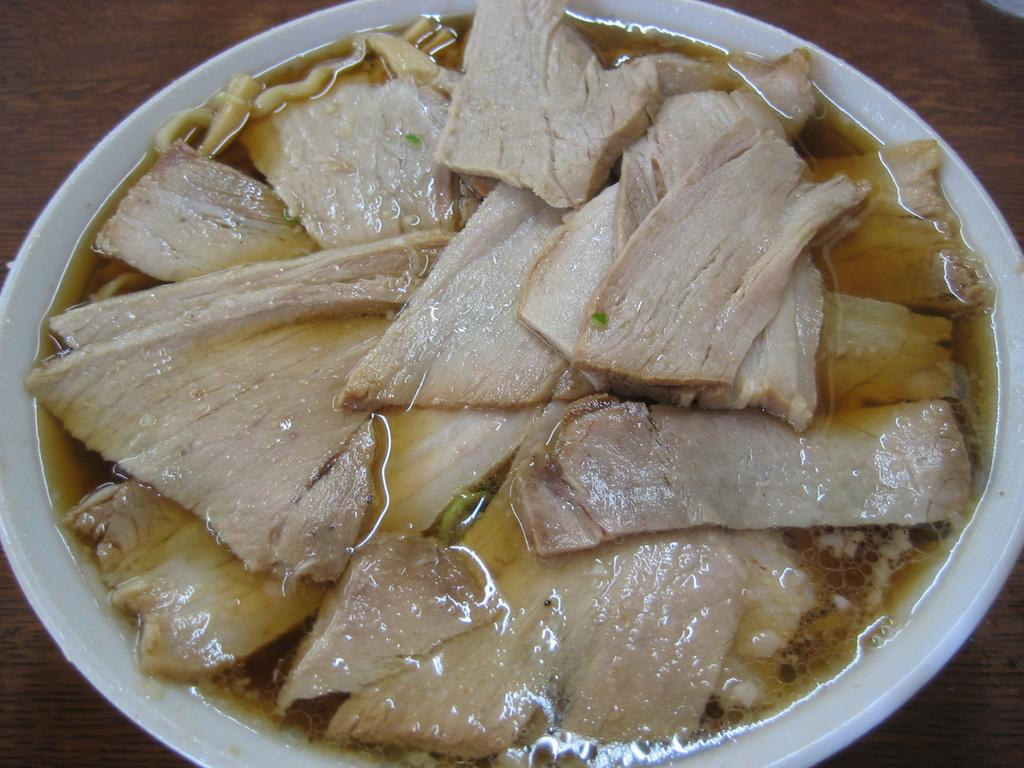What is on the plate that is visible in the image? There is a plate with food in the image. Where is the plate located in the image? The plate is placed on a table. What type of alarm is going off in the image? There is no alarm present in the image. What kind of work is being done in the image? There is no indication of work being done in the image; it only shows a plate with food on a table. 